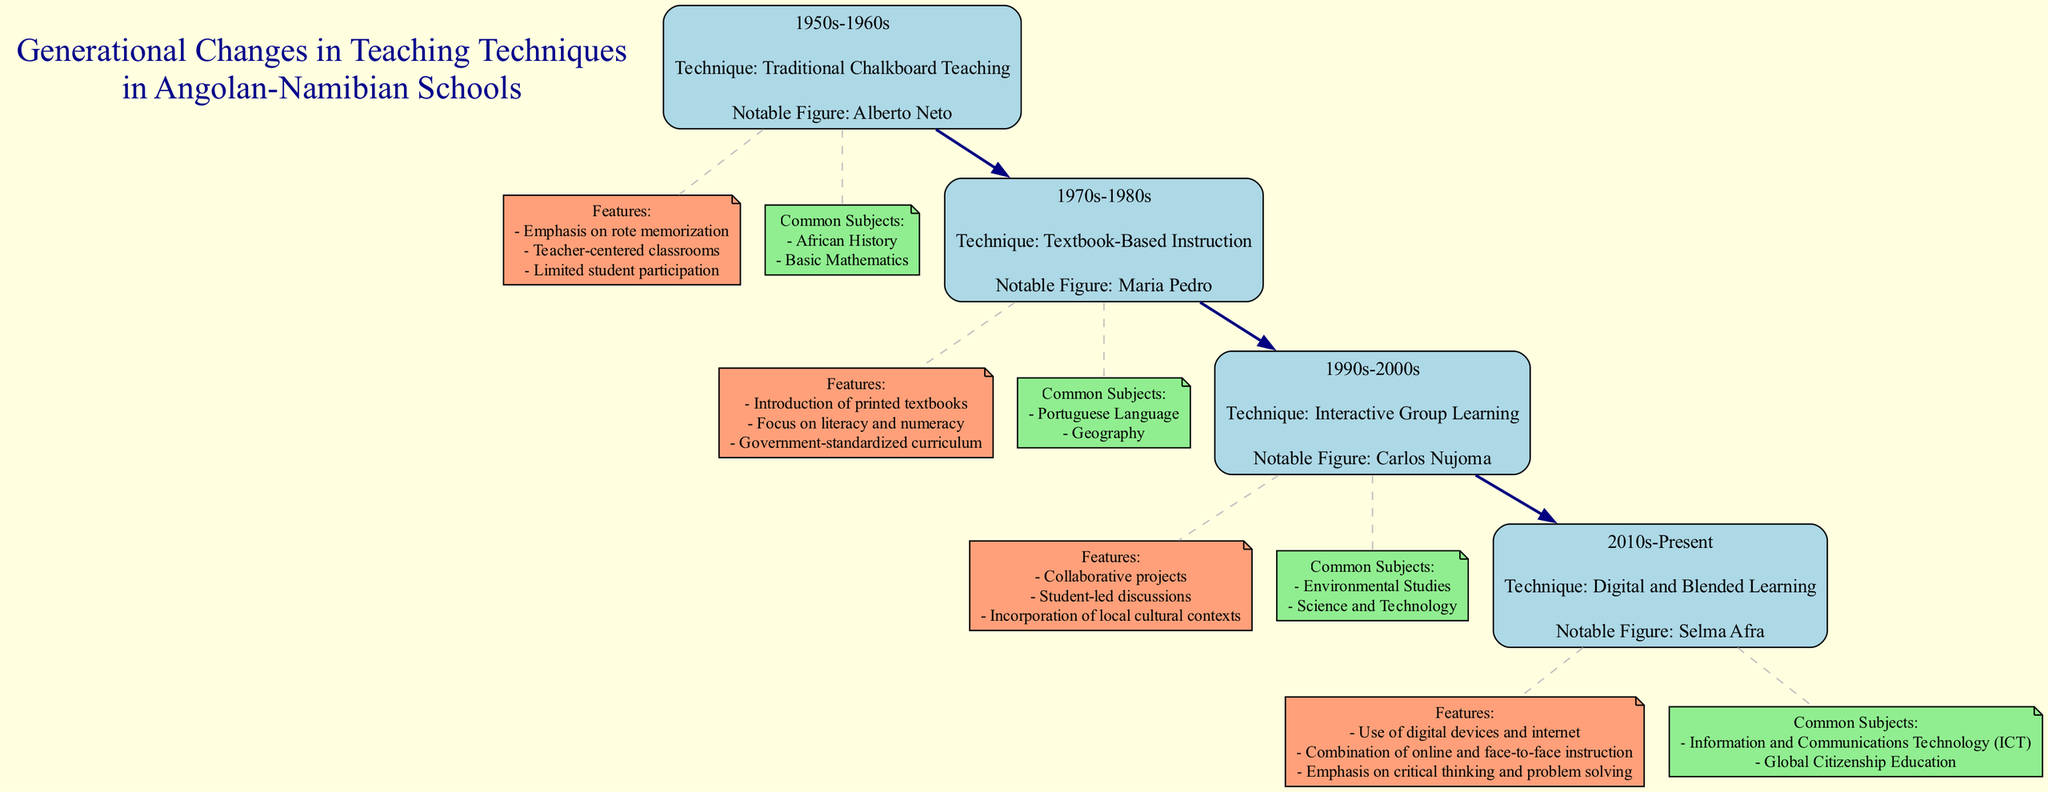What teaching technique was primarily used in the 1950s-1960s? The diagram shows a node for the 1950s-1960s generation that lists "Traditional Chalkboard Teaching" as the technique used during that time. This information is presented clearly in the associated node for that generation.
Answer: Traditional Chalkboard Teaching Who was a notable figure in the 1970s-1980s teaching technique? Looking at the node for the 1970s-1980s, the diagram specifies "Maria Pedro" as the notable figure. Therefore, to answer this question, one just needs to identify the correct node in the diagram and read the notable figure listed.
Answer: Maria Pedro How many generations of teaching techniques are represented in the diagram? By counting the nodes that represent each generation, there are four distinct nodes for the generations ranging from the 1950s-1960s to the 2010s-Present. Thus, the total number of generations is straightforward from the diagram structure.
Answer: 4 Which teaching technique focused on collaborative projects? The technique "Interactive Group Learning" is explicitly listed under the 1990s-2000s generation in the diagram. It's connected to the features section, which mentions "Collaborative projects." This detail allows for a direct association of the technique with its corresponding features.
Answer: Interactive Group Learning What is a common subject taught in the 2010s-Present? In the node for the 2010s-Present generation, the diagram highlights "Information and Communications Technology (ICT)" as one of the common subjects. This straightforward identification comes from the clear labeling in the respective section of the generation node.
Answer: Information and Communications Technology (ICT) What feature distinguishes teaching in the 1980s compared to the 1960s? In the 1980s, the diagram mentions an "Introduction of printed textbooks" as a feature, whereas the 1960s focused on "Emphasis on rote memorization." The comparison highlights a shift from traditional methods to more structured, resource-aided teaching techniques. Such reasoning involves observing shifts in features across the generations.
Answer: Introduction of printed textbooks Which generation saw an emphasis on critical thinking and problem-solving? The diagram indicates that the 2010s-Present generation placed emphasis on "critical thinking and problem solving" as part of its features, thus identifying the growth in educational goals effectively. This information can be found alongside other features listed in the respective node.
Answer: 2010s-Present What is the relationship between the 1970s-1980s and the 1990s-2000s generations in teaching techniques? The 1970s-1980s generation is directly connected to the 1990s-2000s generation in the diagram with a forward-directed edge. This reflects the progression of teaching techniques and signifies a transition in methodologies from one generation of teaching practices to another.
Answer: Progression of teaching techniques 